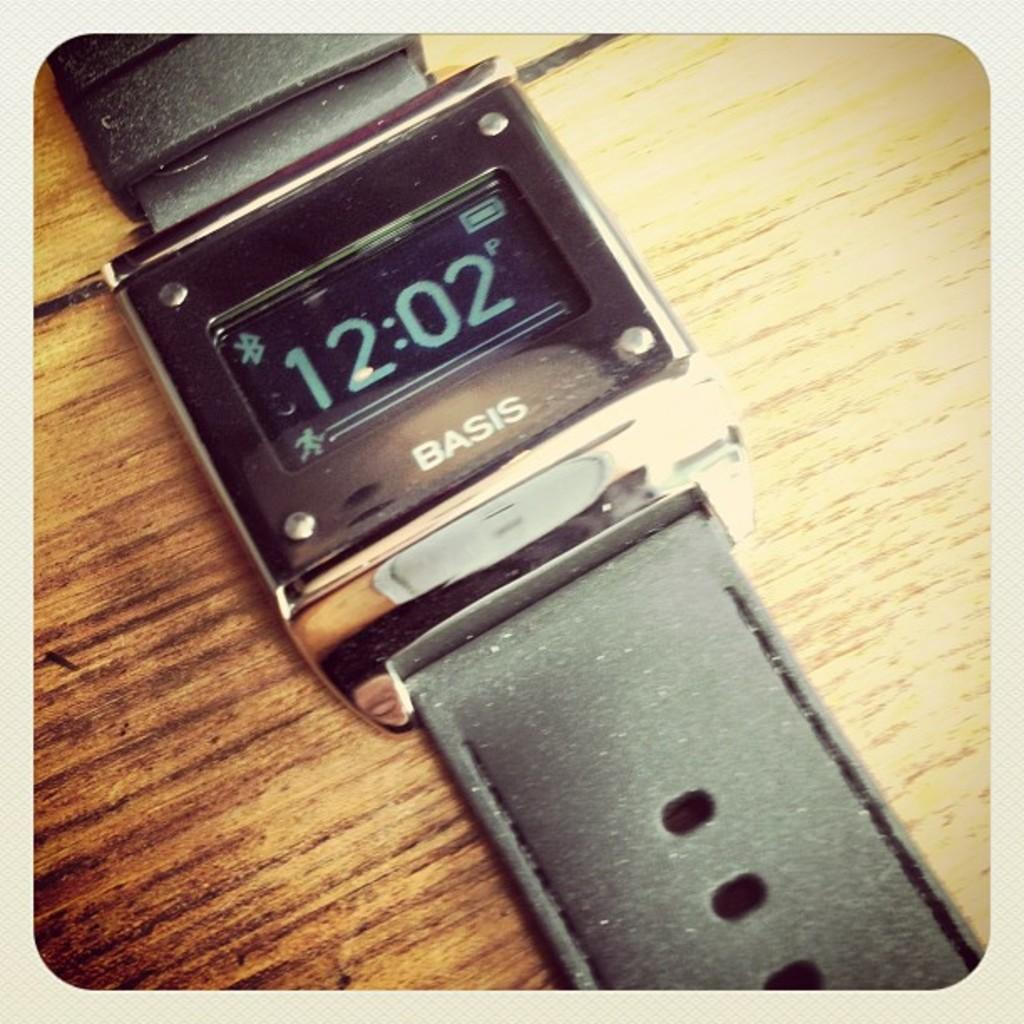<image>
Create a compact narrative representing the image presented. A Basic brand digital watch showing time 12:02. 